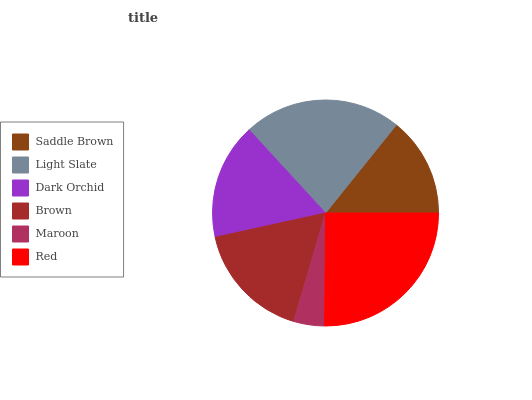Is Maroon the minimum?
Answer yes or no. Yes. Is Red the maximum?
Answer yes or no. Yes. Is Light Slate the minimum?
Answer yes or no. No. Is Light Slate the maximum?
Answer yes or no. No. Is Light Slate greater than Saddle Brown?
Answer yes or no. Yes. Is Saddle Brown less than Light Slate?
Answer yes or no. Yes. Is Saddle Brown greater than Light Slate?
Answer yes or no. No. Is Light Slate less than Saddle Brown?
Answer yes or no. No. Is Brown the high median?
Answer yes or no. Yes. Is Dark Orchid the low median?
Answer yes or no. Yes. Is Light Slate the high median?
Answer yes or no. No. Is Light Slate the low median?
Answer yes or no. No. 